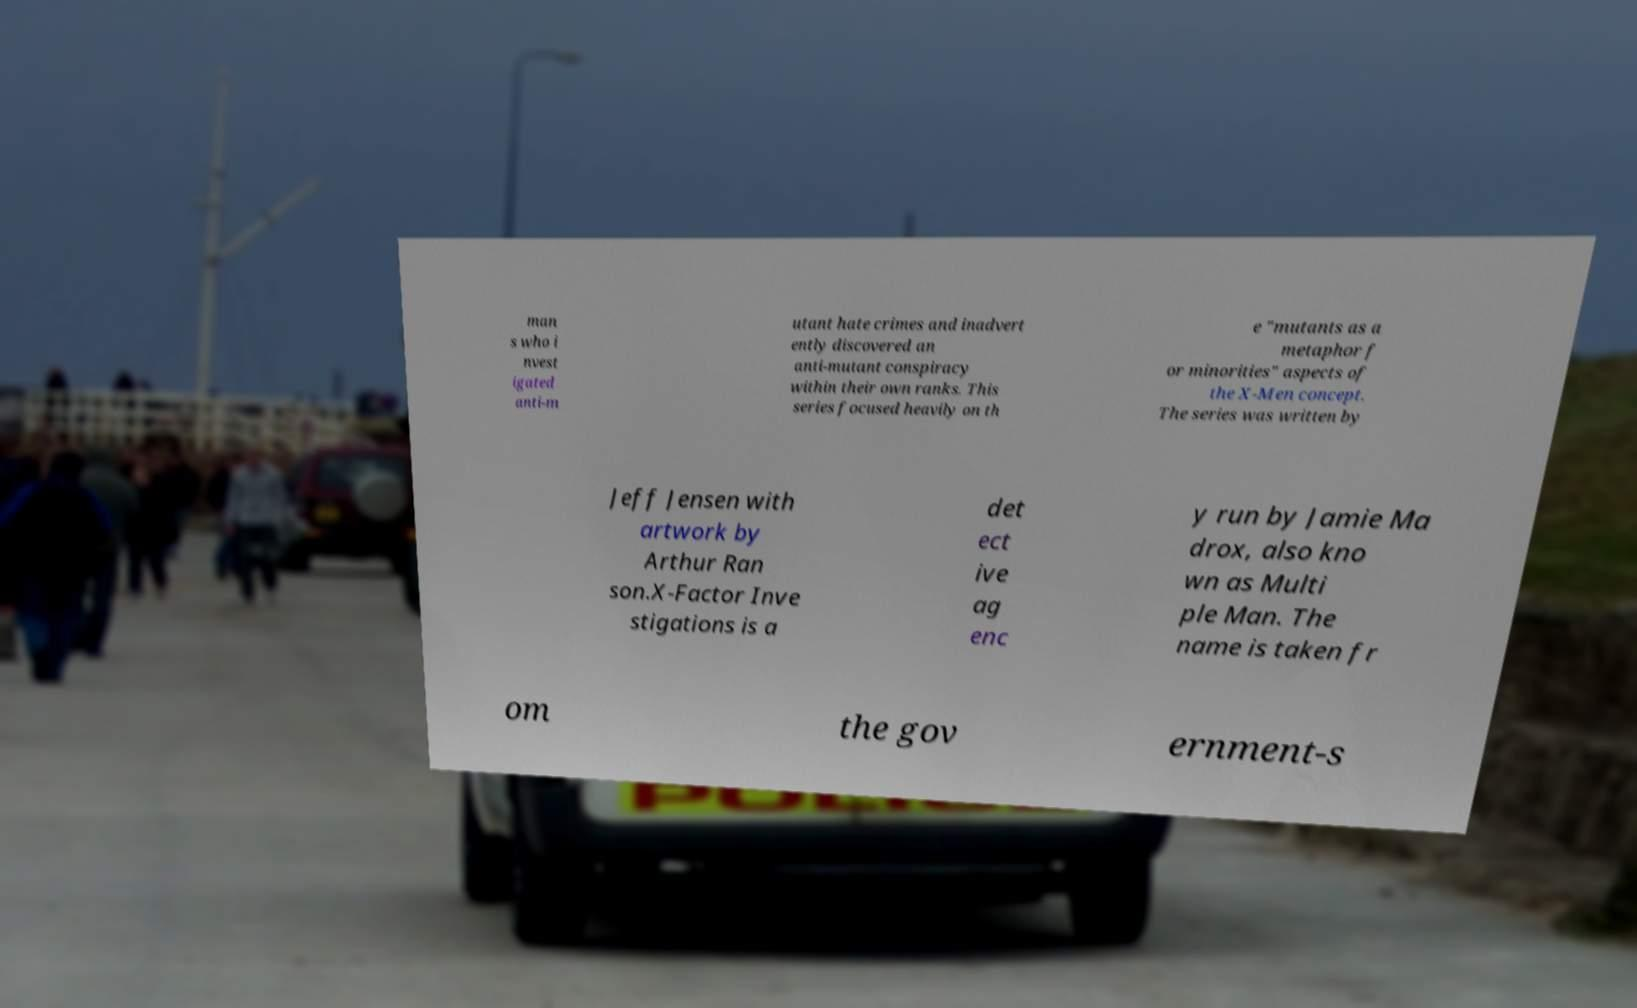What messages or text are displayed in this image? I need them in a readable, typed format. man s who i nvest igated anti-m utant hate crimes and inadvert ently discovered an anti-mutant conspiracy within their own ranks. This series focused heavily on th e "mutants as a metaphor f or minorities" aspects of the X-Men concept. The series was written by Jeff Jensen with artwork by Arthur Ran son.X-Factor Inve stigations is a det ect ive ag enc y run by Jamie Ma drox, also kno wn as Multi ple Man. The name is taken fr om the gov ernment-s 